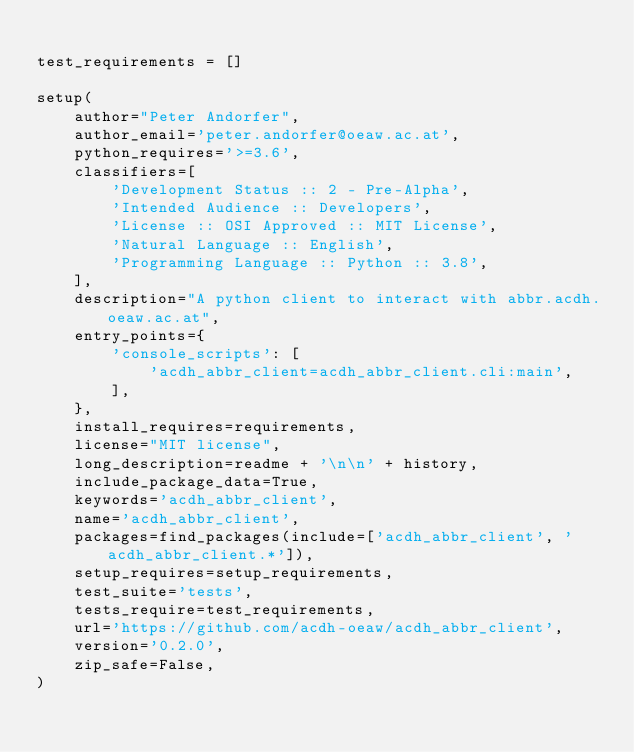<code> <loc_0><loc_0><loc_500><loc_500><_Python_>
test_requirements = []

setup(
    author="Peter Andorfer",
    author_email='peter.andorfer@oeaw.ac.at',
    python_requires='>=3.6',
    classifiers=[
        'Development Status :: 2 - Pre-Alpha',
        'Intended Audience :: Developers',
        'License :: OSI Approved :: MIT License',
        'Natural Language :: English',
        'Programming Language :: Python :: 3.8',
    ],
    description="A python client to interact with abbr.acdh.oeaw.ac.at",
    entry_points={
        'console_scripts': [
            'acdh_abbr_client=acdh_abbr_client.cli:main',
        ],
    },
    install_requires=requirements,
    license="MIT license",
    long_description=readme + '\n\n' + history,
    include_package_data=True,
    keywords='acdh_abbr_client',
    name='acdh_abbr_client',
    packages=find_packages(include=['acdh_abbr_client', 'acdh_abbr_client.*']),
    setup_requires=setup_requirements,
    test_suite='tests',
    tests_require=test_requirements,
    url='https://github.com/acdh-oeaw/acdh_abbr_client',
    version='0.2.0',
    zip_safe=False,
)
</code> 